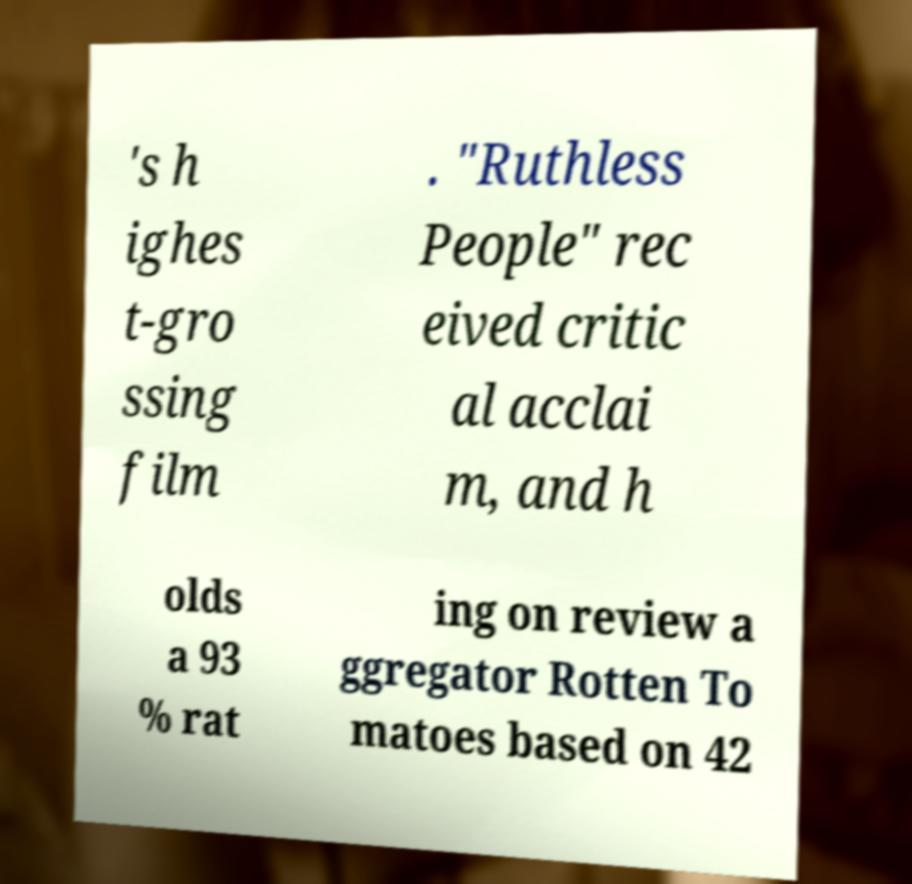Please read and relay the text visible in this image. What does it say? 's h ighes t-gro ssing film . "Ruthless People" rec eived critic al acclai m, and h olds a 93 % rat ing on review a ggregator Rotten To matoes based on 42 